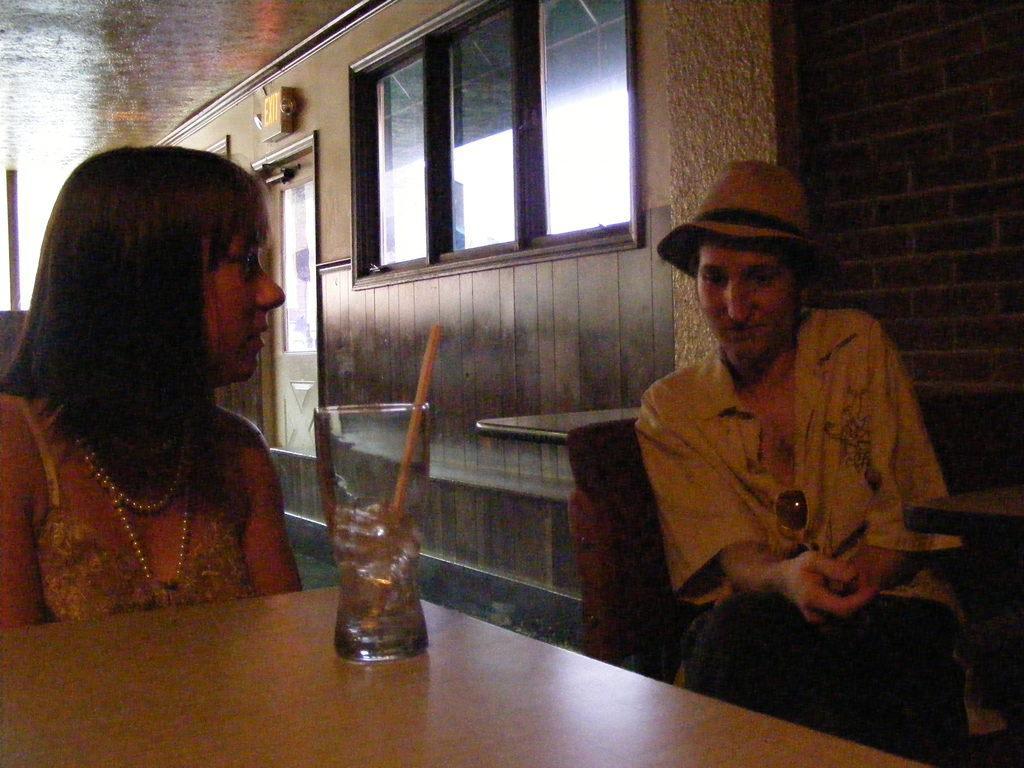Could you give a brief overview of what you see in this image? This picture shows two people sitting on the chair and we see a glass with a straw on the table 